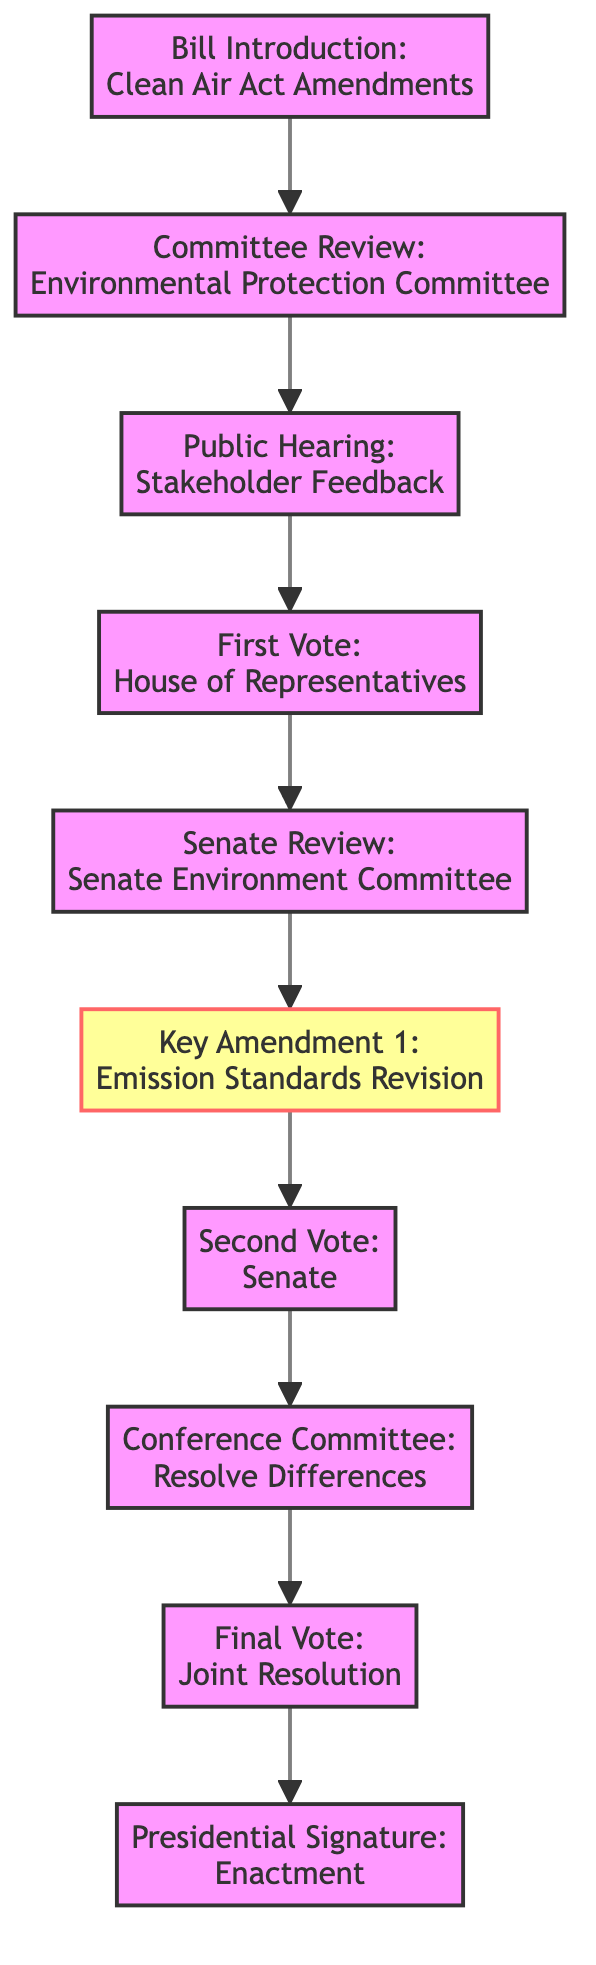What is the first step in the legislative timeline? The first node in the diagram is "Bill Introduction: Clean Air Act Amendments," which indicates the initial step of the legislative process.
Answer: Bill Introduction: Clean Air Act Amendments How many nodes are in the diagram? Counting the nodes listed in the provided data, there are a total of 10 nodes representing distinct steps in the legislative timeline.
Answer: 10 What follows the "Public Hearing: Stakeholder Feedback"? The edge from "Public Hearing: Stakeholder Feedback" points to "First Vote: House of Representatives," showing the next step in the process.
Answer: First Vote: House of Representatives What is Key Amendment 1 about? The label for Key Amendment 1 is "Emission Standards Revision," which indicates the content of this amendment within the legislative timeline.
Answer: Emission Standards Revision What is the relationship between "Senate Review: Senate Environment Committee" and "Key Amendment 1"? The directed edge connects "Senate Review: Senate Environment Committee" to "Key Amendment 1," denoting that the Senate Review leads to discussions of this Key Amendment.
Answer: Leads to How many amendments are highlighted in the diagram? There is specifically one node labeled as an amendment, which is "Key Amendment 1: Emission Standards Revision."
Answer: 1 What is the final step in the legislative process depicted in the graph? The last node shown is "Presidential Signature: Enactment," indicating the finalization of the legislative process.
Answer: Presidential Signature: Enactment Which vote occurs before the "Conference Committee: Resolve Differences"? The "Second Vote: Senate" occurs just prior to the "Conference Committee," as shown by the directed edge in the diagram.
Answer: Second Vote: Senate What type of feedback occurs during the "Public Hearing"? The label mentions "Stakeholder Feedback," indicating that feedback is collected from stakeholders during this phase of the legislative timeline.
Answer: Stakeholder Feedback 